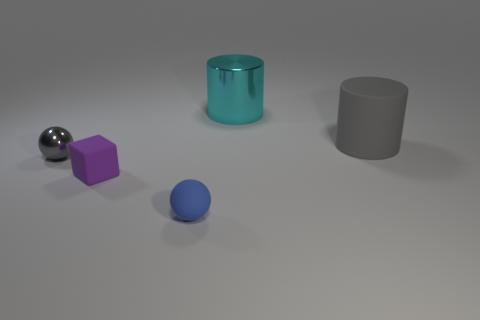The cyan metal object is what size?
Ensure brevity in your answer.  Large. There is a big matte cylinder; is it the same color as the shiny object to the left of the tiny purple thing?
Provide a succinct answer. Yes. What color is the big thing behind the gray object that is behind the tiny metallic object?
Your response must be concise. Cyan. Does the gray object that is right of the rubber sphere have the same shape as the blue rubber object?
Offer a terse response. No. What number of rubber objects are in front of the small rubber block and right of the cyan thing?
Offer a terse response. 0. The matte object to the left of the ball on the right side of the purple rubber object in front of the tiny gray thing is what color?
Your response must be concise. Purple. There is a gray object on the left side of the blue rubber thing; how many small purple matte things are behind it?
Make the answer very short. 0. How many other things are there of the same shape as the small purple rubber thing?
Offer a terse response. 0. What number of things are purple things or gray things on the left side of the tiny blue rubber sphere?
Your response must be concise. 2. Is the number of tiny gray metal objects left of the purple block greater than the number of small purple rubber objects to the right of the cyan cylinder?
Your answer should be compact. Yes. 